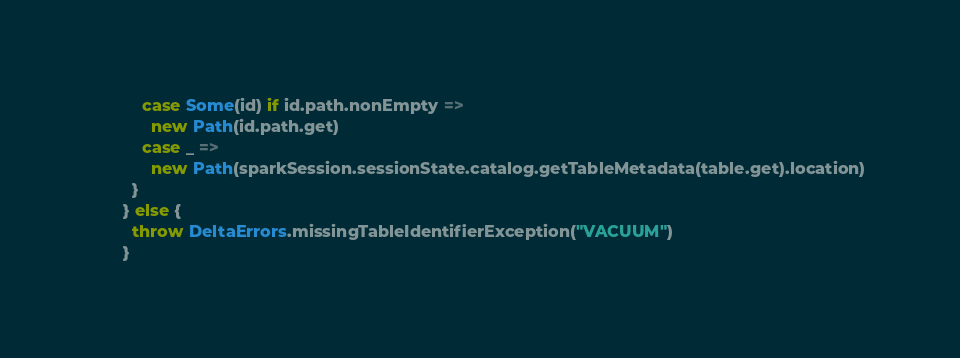<code> <loc_0><loc_0><loc_500><loc_500><_Scala_>          case Some(id) if id.path.nonEmpty =>
            new Path(id.path.get)
          case _ =>
            new Path(sparkSession.sessionState.catalog.getTableMetadata(table.get).location)
        }
      } else {
        throw DeltaErrors.missingTableIdentifierException("VACUUM")
      }</code> 